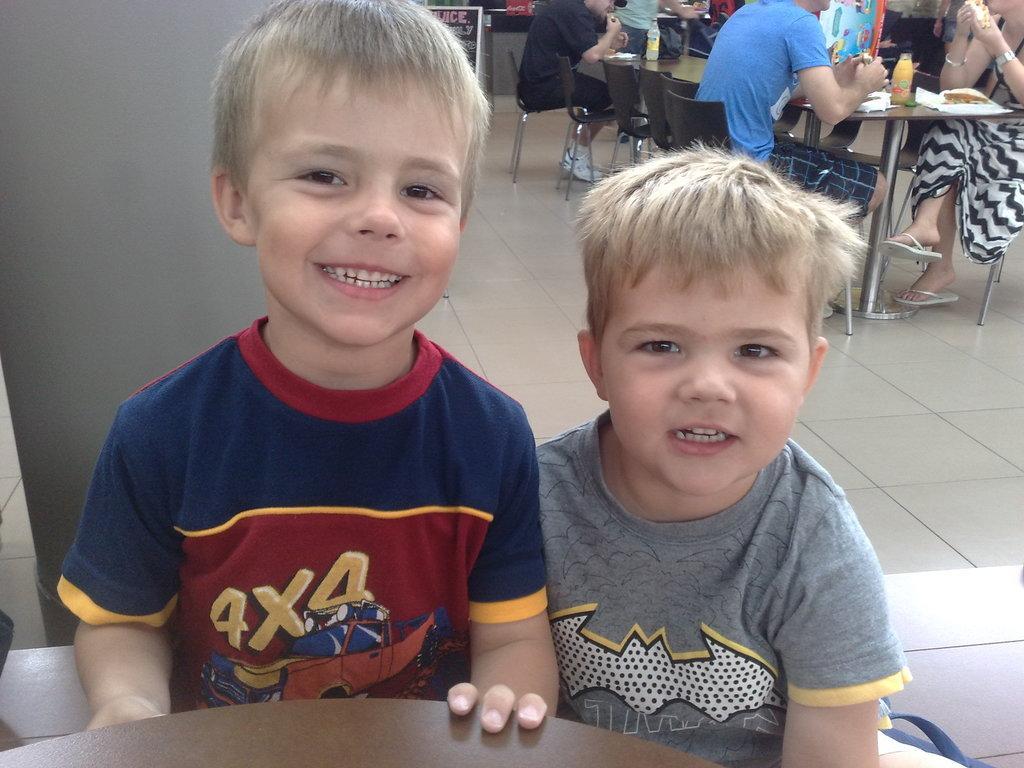Could you give a brief overview of what you see in this image? These persons are sitting on the chairs. We can see bottles,food on the table. This is floor. Behind these two persons we can see a pillar. 